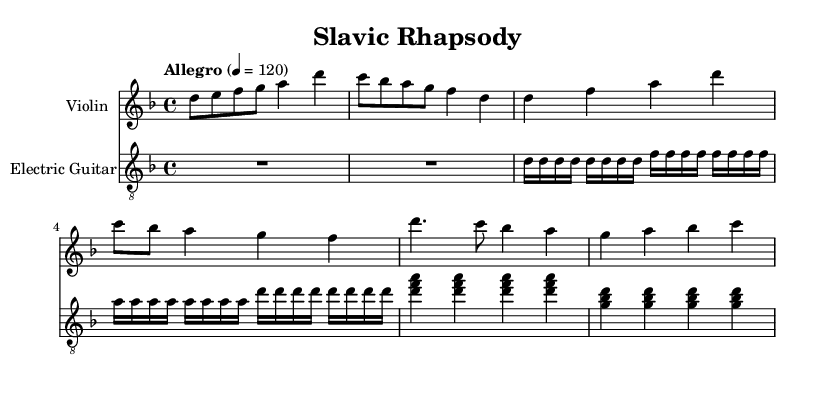What is the key signature of this music? The key signature shows two flats (B♭ and E♭), indicating the key of D minor.
Answer: D minor What is the time signature of the piece? The time signature is indicated at the beginning of the score as 4/4, meaning there are four beats in each measure, and the quarter note gets one beat.
Answer: 4/4 What is the tempo marking? The tempo marking in the score indicates "Allegro" with a metronome marking of 120 beats per minute, which means the piece should be played fast.
Answer: Allegro 4 = 120 What is the instrument that plays the melody in the intro? The melody in the intro is played by the Violin, as denoted by the instrument name at the beginning of the staff.
Answer: Violin How many measures are in the verse section? The verse section comprises four measures as indicated by the music notation, where each line consists of two measures and there are two lines for the verse.
Answer: 4 What musical characteristics make this piece symphonic metal? The piece incorporates classical elements, including orchestral instrumentation like the Violin, combined with heavy electric guitar riffs, which is typical in symphonic metal.
Answer: Orchestral instrumentation and heavy guitar riffs What is the chord established in the chorus? The chorus section establishes the chord D minor through the notes D, F, and A, which are harmonized and played together, creating the D minor triad.
Answer: D minor triad 